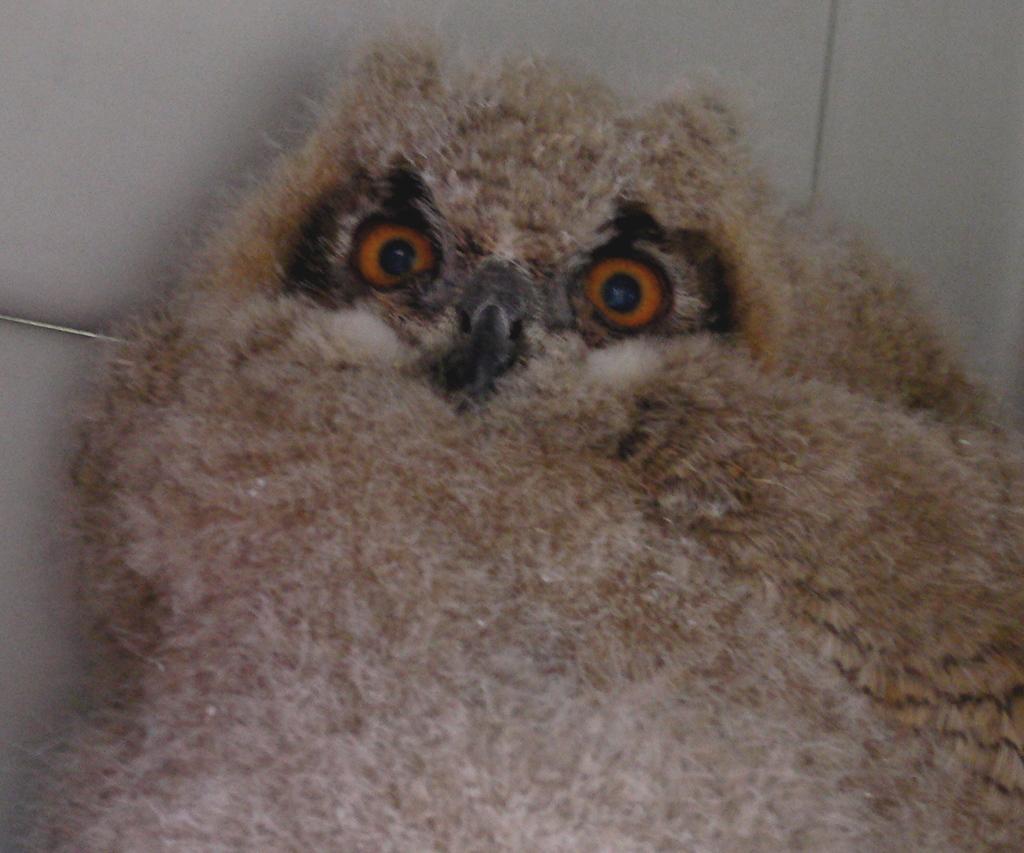Describe this image in one or two sentences. In this picture there is a light brown color owl. At the back there is a white color background. 